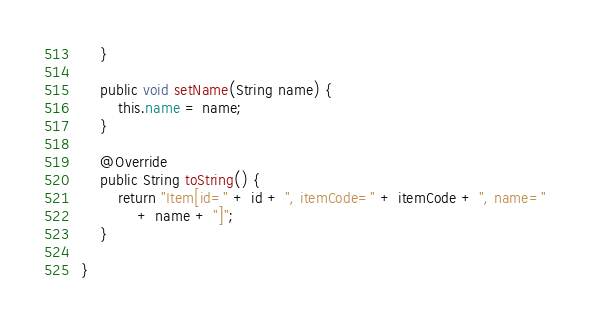Convert code to text. <code><loc_0><loc_0><loc_500><loc_500><_Java_>    }

    public void setName(String name) {
        this.name = name;
    }

    @Override
    public String toString() {
        return "Item[id=" + id + ", itemCode=" + itemCode + ", name="
            + name + "]";
    }

}</code> 